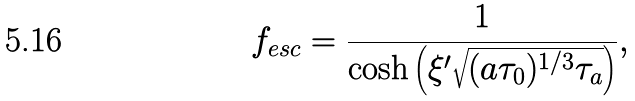Convert formula to latex. <formula><loc_0><loc_0><loc_500><loc_500>f _ { e s c } = \frac { 1 } { \cosh \left ( \xi ^ { \prime } \sqrt { ( a \tau _ { 0 } ) ^ { 1 / 3 } \tau _ { a } } \right ) } ,</formula> 